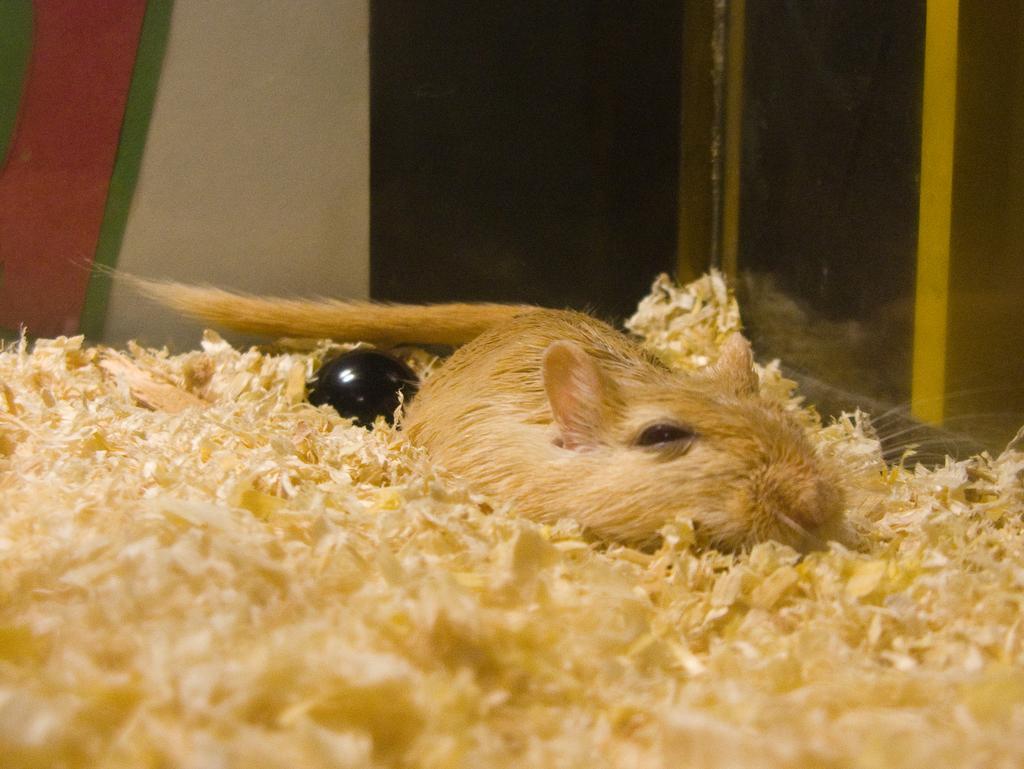How would you summarize this image in a sentence or two? In the image there is an animal kept in a glass box,around the animal there is some waste material. 